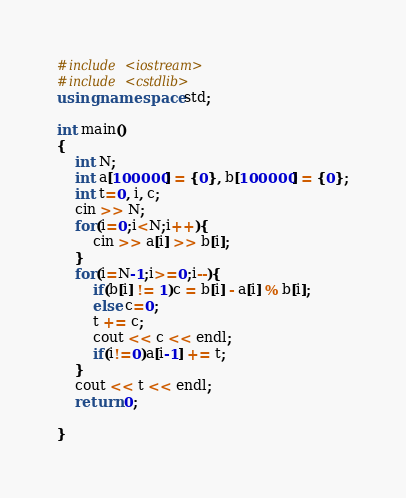Convert code to text. <code><loc_0><loc_0><loc_500><loc_500><_C++_>#include <iostream>
#include <cstdlib>
using namespace std;

int main()
{
    int N;
    int a[100000] = {0}, b[100000] = {0};
    int t=0, i, c;
    cin >> N;
    for(i=0;i<N;i++){
        cin >> a[i] >> b[i];
    }
    for(i=N-1;i>=0;i--){
        if(b[i] != 1)c = b[i] - a[i] % b[i];
        else c=0;
        t += c;
        cout << c << endl;
        if(i!=0)a[i-1] += t;
    }
    cout << t << endl;
    return 0;

}</code> 